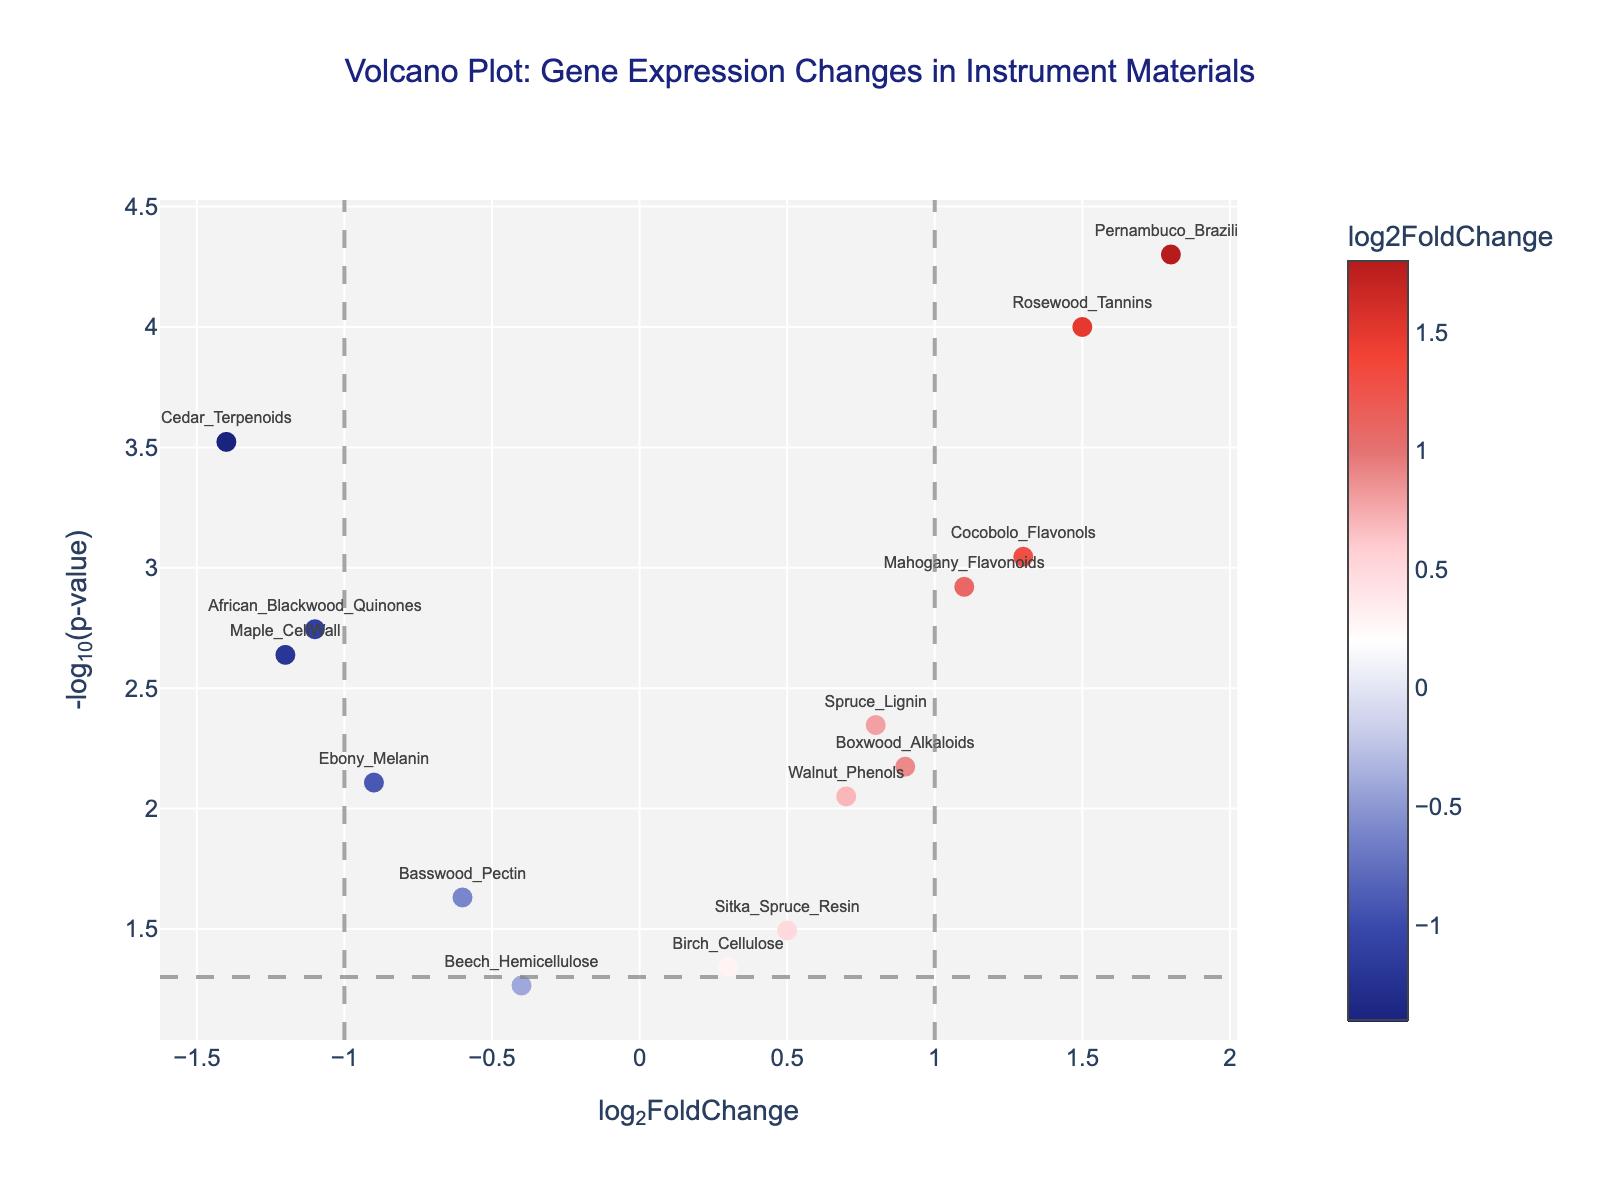What is the title of the figure? The title is located at the top of the figure and describes the content of the plot. In this case, it is "Volcano Plot: Gene Expression Changes in Instrument Materials".
Answer: Volcano Plot: Gene Expression Changes in Instrument Materials How many data points are shown in the figure? By counting the markers on the plot, we can determine the number of data points. There are 14 data points visible.
Answer: 14 Which gene has the highest log2FoldChange value? Locate the point farthest to the right on the x-axis (log2FoldChange axis). The gene with the highest log2FoldChange is "Pernambuco_Brazilin" with a log2FoldChange of 1.8.
Answer: Pernambuco_Brazilin What is the p-value threshold line in the figure? The threshold line is indicated by a horizontal dashed line. It represents a p-value of 0.05, which translates to a -log10(p-value) of 1.3.
Answer: 0.05 Which gene has a log2FoldChange less than -1 and a p-value less than 0.05? Find points in the lower left quadrant based on the given thresholds; these are data points with log2FoldChange < -1 and -log10(p-value) > 1.3. The gene "Cedar_Terpenoids" fits these criteria.
Answer: Cedar_Terpenoids How many genes have a p-value less than 0.01? Count the points above the -log10(p-value) threshold line of 2 (since -log10(0.01) = 2). There are 7 genes: Maple_CellWall, Spruce_Lignin, Rosewood_Tannins, Mahogany_Flavonoids, Cedar_Terpenoids, Pernambuco_Brazilin, and African_Blackwood_Quinones.
Answer: 7 Which genes have a log2FoldChange between -0.5 and 0.5? Identify points that fall between -0.5 and 0.5 on the x-axis. These genes are Birch_Cellulose, Basswood_Pectin, Sitka_Spruce_Resin, and Beech_Hemicellulose.
Answer: Birch_Cellulose, Basswood_Pectin, Sitka_Spruce_Resin, Beech_Hemicellulose Is "Walnut_Phenols" gene up-regulated or down-regulated? Check the sign of "Walnut_Phenols" log2FoldChange value. A positive value indicates up-regulation, and a negative value indicates down-regulation. The log2FoldChange for "Walnut_Phenols" is 0.7, meaning it is up-regulated.
Answer: Up-regulated Which gene has the highest -log10(p-value)? Locate the point farthest up on the y-axis (-log10(p-value) axis). The gene with the highest -log10(p-value) is "Pernambuco_Brazilin".
Answer: Pernambuco_Brazilin 